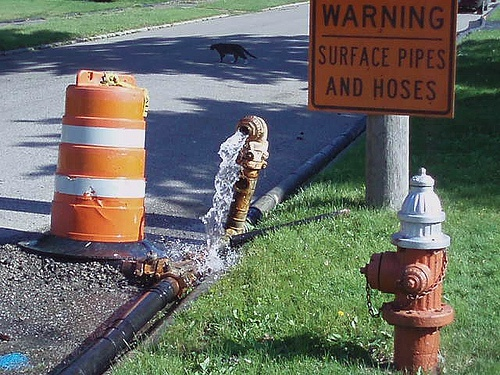Describe the objects in this image and their specific colors. I can see fire hydrant in green, black, maroon, lightgray, and brown tones and cat in green, black, navy, darkblue, and blue tones in this image. 